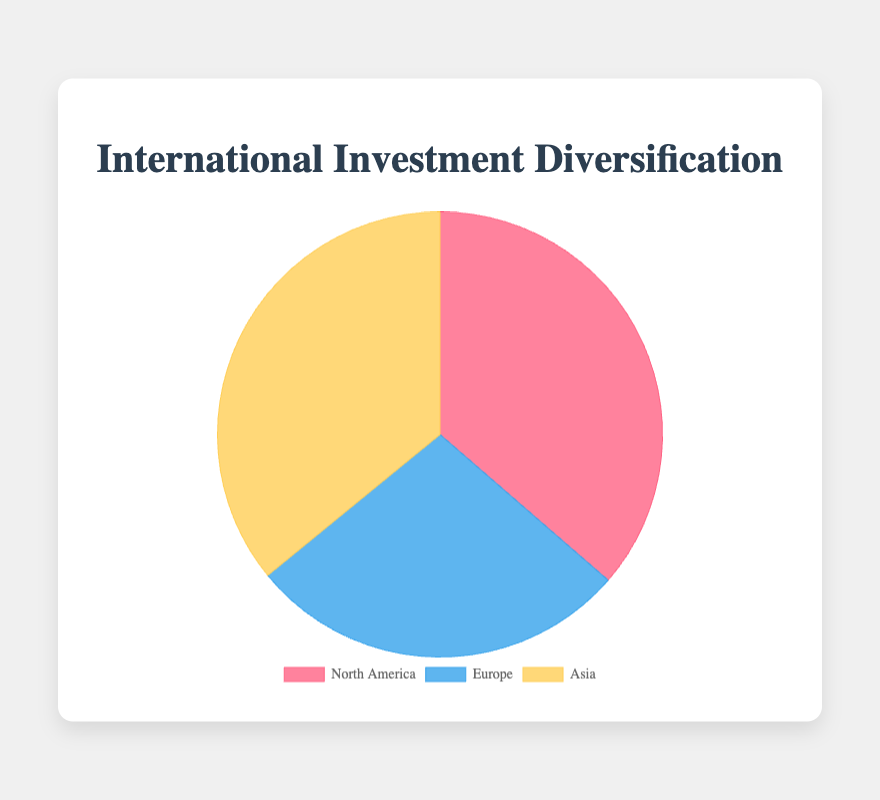What is the total amount invested in North America? To find the total amount invested in North America, sum the investment amounts for "Apple Inc.", "Microsoft Corporation", and "Amazon.com Inc.". Hence, $1,500,000 + $1,300,000 + $1,200,000 = $4,000,000.
Answer: $4,000,000 What percentage of the total investments is allocated to Europe? First calculate the total investments across all regions. North America: $4,000,000, Europe: $2,950,000, Asia: $3,950,000. Total investments: $4,000,000 + $2,950,000 + $3,950,000 = $10,900,000. The amount invested in Europe is $2,950,000. To find the percentage: ($2,950,000 / $10,900,000) * 100 ≈ 27.1%.
Answer: 27.1% Which region receives the highest investment? Compare the total investments across regions: North America: $4,000,000, Europe: $2,950,000, Asia: $3,950,000. North America has the highest investment, $4,000,000.
Answer: North America How much less is invested in Europe compared to Asia? Subtract the total investment in Europe from that in Asia. Asia: $3,950,000 - Europe: $2,950,000 = $1,000,000.
Answer: $1,000,000 What color represents Asia in the Pie chart? According to the given code snippet, the color assigned to Asia is yellow.
Answer: yellow What is the total investment amount across all regions? Sum the investment amounts for North America, Europe, and Asia. Thus, $4,000,000 + $2,950,000 + $3,950,000 = $10,900,000.
Answer: $10,900,000 Which region has the smallest share of the total investments? Compare the total investments in each region. North America: $4,000,000, Europe: $2,950,000, Asia: $3,950,000. Europe has the smallest share with $2,950,000.
Answer: Europe What is the average investment amount per company in Asia? Asia total investment: $3,950,000. There are 3 companies. Average = $3,950,000 / 3 ≈ $1,316,667.
Answer: $1,316,667 Which region's investment amount is represented by the blue color? According to the given code snippet, the blue color is assigned to Europe.
Answer: Europe 